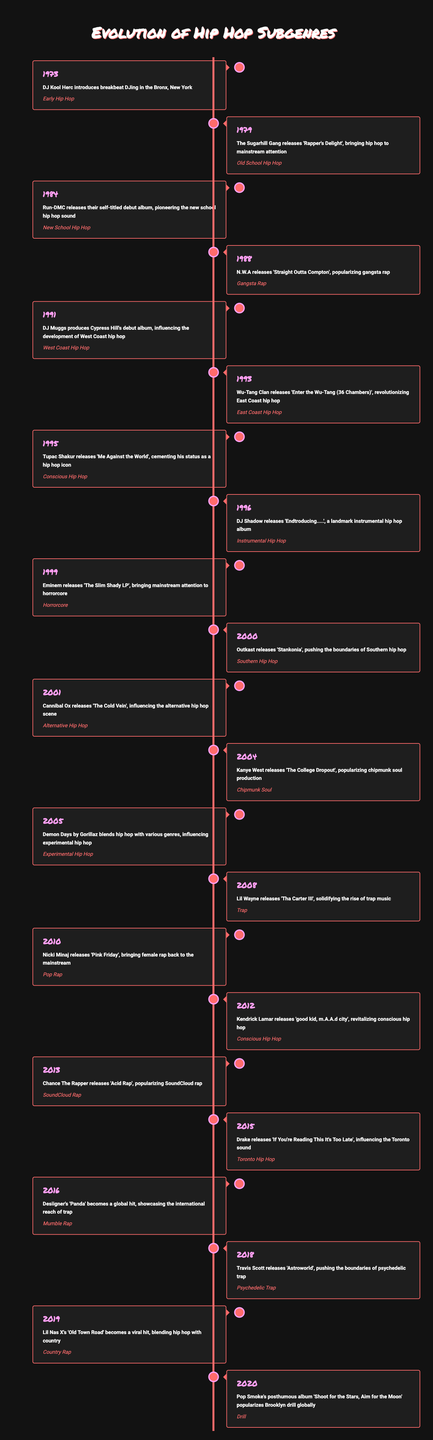What year did DJ Kool Herc introduce breakbeat DJing? The table shows that DJ Kool Herc introduced breakbeat DJing in 1973.
Answer: 1973 Which subgenre was popularized by N.W.A's release of "Straight Outta Compton"? The table indicates that N.W.A popularized gangsta rap with the release of "Straight Outta Compton" in 1988.
Answer: Gangsta Rap How many hip hop subgenres were introduced in the 1990s? By counting the rows under the years 1990 to 1999, there are five subgenres introduced: West Coast Hip Hop (1991), East Coast Hip Hop (1993), Conscious Hip Hop (1995), Instrumental Hip Hop (1996), and Horrorcore (1999).
Answer: 5 Had there been a significant rise in trap music by 2008? According to the table, Lil Wayne's release of "Tha Carter III" in 2008 solidified the rise of trap music, indicating a significant rise in this subgenre.
Answer: Yes In what year did two distinct types of hip hop subgenres appear involving conscious themes? The table shows that Conscious Hip Hop was represented by two albums: Tupac Shakur's "Me Against the World" in 1995 and Kendrick Lamar's "good kid, m.A.A.d city" in 2012, together indicating 1995 and 2012 as the years showing conscious themes.
Answer: 1995 and 2012 What subgenre did Eminem contribute to with his album "The Slim Shady LP"? The table states that Eminem's "The Slim Shady LP," which was released in 1999, brought mainstream attention to horrorcore.
Answer: Horrorcore Which subgenre did Kendrick Lamar's debut contribute to in 2012? As indicated in the timeline, Kendrick Lamar's album "good kid, m.A.A.d city," released in 2012, revitalized conscious hip hop.
Answer: Conscious Hip Hop How many years passed between the introduction of old school hip hop and the rise of trap music? Old School Hip Hop was introduced in 1979, and trap music rose in popularity in 2008. The years between 1979 and 2008 span 29 years (2008 - 1979 = 29).
Answer: 29 years What do the years 2013 and 2020 suggest about trends in hip hop? In 2013, SoundCloud rap emerged with Chance The Rapper's "Acid Rap," and in 2020 Brooklyn drill was popularized globally by Pop Smoke's posthumous album, suggesting that hip hop continues to evolve with new platforms and styles over these years.
Answer: Evolving trends 